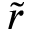Convert formula to latex. <formula><loc_0><loc_0><loc_500><loc_500>\tilde { r }</formula> 